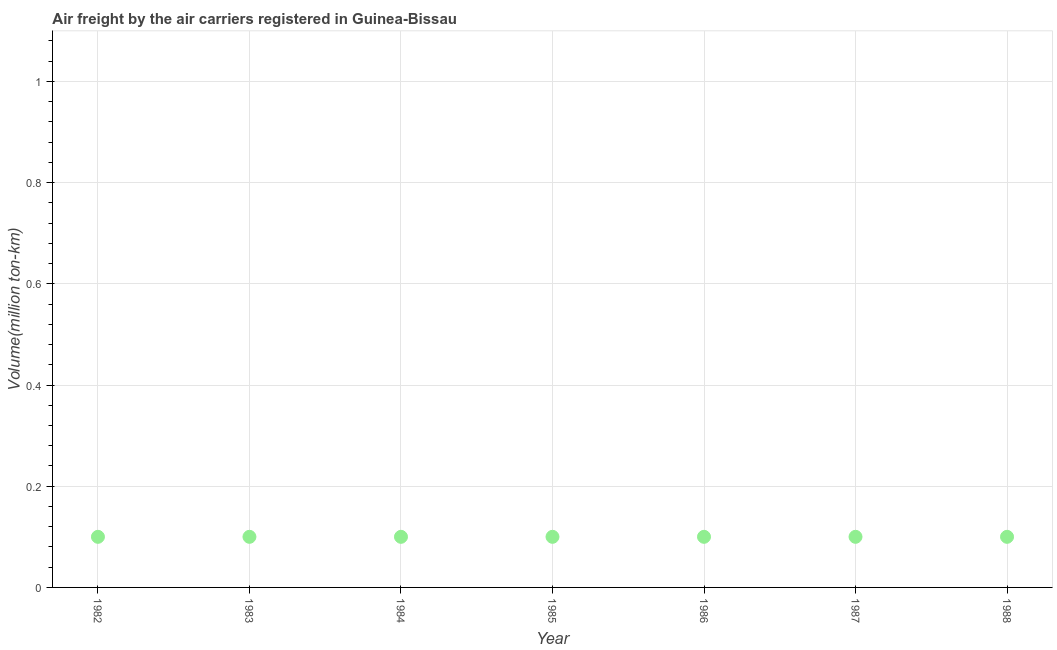What is the air freight in 1984?
Keep it short and to the point. 0.1. Across all years, what is the maximum air freight?
Ensure brevity in your answer.  0.1. Across all years, what is the minimum air freight?
Give a very brief answer. 0.1. In which year was the air freight maximum?
Provide a succinct answer. 1982. In which year was the air freight minimum?
Make the answer very short. 1982. What is the sum of the air freight?
Keep it short and to the point. 0.7. What is the average air freight per year?
Provide a succinct answer. 0.1. What is the median air freight?
Provide a succinct answer. 0.1. Do a majority of the years between 1983 and 1988 (inclusive) have air freight greater than 0.44 million ton-km?
Your answer should be very brief. No. What is the ratio of the air freight in 1982 to that in 1986?
Keep it short and to the point. 1. Is the air freight in 1982 less than that in 1984?
Offer a very short reply. No. In how many years, is the air freight greater than the average air freight taken over all years?
Provide a succinct answer. 0. Does the graph contain any zero values?
Your answer should be compact. No. What is the title of the graph?
Ensure brevity in your answer.  Air freight by the air carriers registered in Guinea-Bissau. What is the label or title of the Y-axis?
Provide a succinct answer. Volume(million ton-km). What is the Volume(million ton-km) in 1982?
Make the answer very short. 0.1. What is the Volume(million ton-km) in 1983?
Provide a short and direct response. 0.1. What is the Volume(million ton-km) in 1984?
Your answer should be very brief. 0.1. What is the Volume(million ton-km) in 1985?
Give a very brief answer. 0.1. What is the Volume(million ton-km) in 1986?
Your answer should be very brief. 0.1. What is the Volume(million ton-km) in 1987?
Provide a succinct answer. 0.1. What is the Volume(million ton-km) in 1988?
Make the answer very short. 0.1. What is the difference between the Volume(million ton-km) in 1982 and 1985?
Keep it short and to the point. 0. What is the difference between the Volume(million ton-km) in 1982 and 1986?
Make the answer very short. 0. What is the difference between the Volume(million ton-km) in 1982 and 1988?
Ensure brevity in your answer.  0. What is the difference between the Volume(million ton-km) in 1984 and 1986?
Offer a very short reply. 0. What is the difference between the Volume(million ton-km) in 1985 and 1986?
Keep it short and to the point. 0. What is the difference between the Volume(million ton-km) in 1985 and 1987?
Give a very brief answer. 0. What is the difference between the Volume(million ton-km) in 1985 and 1988?
Give a very brief answer. 0. What is the difference between the Volume(million ton-km) in 1986 and 1987?
Your response must be concise. 0. What is the difference between the Volume(million ton-km) in 1986 and 1988?
Give a very brief answer. 0. What is the ratio of the Volume(million ton-km) in 1982 to that in 1984?
Your response must be concise. 1. What is the ratio of the Volume(million ton-km) in 1982 to that in 1986?
Your response must be concise. 1. What is the ratio of the Volume(million ton-km) in 1982 to that in 1987?
Provide a short and direct response. 1. What is the ratio of the Volume(million ton-km) in 1985 to that in 1986?
Give a very brief answer. 1. What is the ratio of the Volume(million ton-km) in 1986 to that in 1988?
Offer a very short reply. 1. 